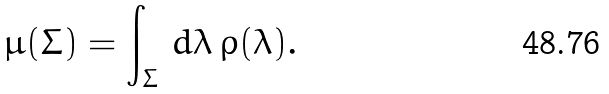Convert formula to latex. <formula><loc_0><loc_0><loc_500><loc_500>\mu ( \Sigma ) = \int _ { \Sigma } \, d \lambda \, \rho ( \lambda ) .</formula> 